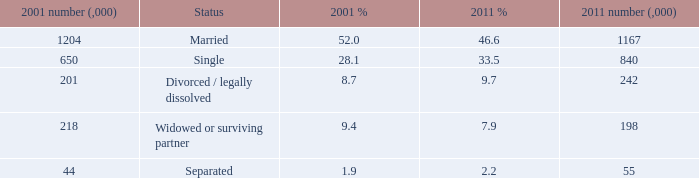What is the lowest 2011 number (,000)? 55.0. Give me the full table as a dictionary. {'header': ['2001 number (,000)', 'Status', '2001 %', '2011 %', '2011 number (,000)'], 'rows': [['1204', 'Married', '52.0', '46.6', '1167'], ['650', 'Single', '28.1', '33.5', '840'], ['201', 'Divorced / legally dissolved', '8.7', '9.7', '242'], ['218', 'Widowed or surviving partner', '9.4', '7.9', '198'], ['44', 'Separated', '1.9', '2.2', '55']]} 